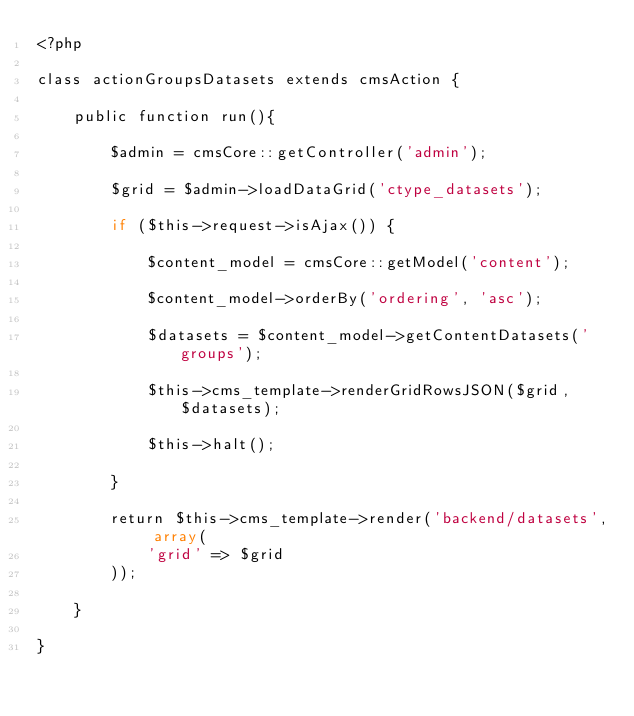<code> <loc_0><loc_0><loc_500><loc_500><_PHP_><?php

class actionGroupsDatasets extends cmsAction {

    public function run(){

        $admin = cmsCore::getController('admin');

        $grid = $admin->loadDataGrid('ctype_datasets');

        if ($this->request->isAjax()) {

            $content_model = cmsCore::getModel('content');

            $content_model->orderBy('ordering', 'asc');

            $datasets = $content_model->getContentDatasets('groups');

            $this->cms_template->renderGridRowsJSON($grid, $datasets);

            $this->halt();

        }

        return $this->cms_template->render('backend/datasets', array(
            'grid' => $grid
        ));

    }

}
</code> 